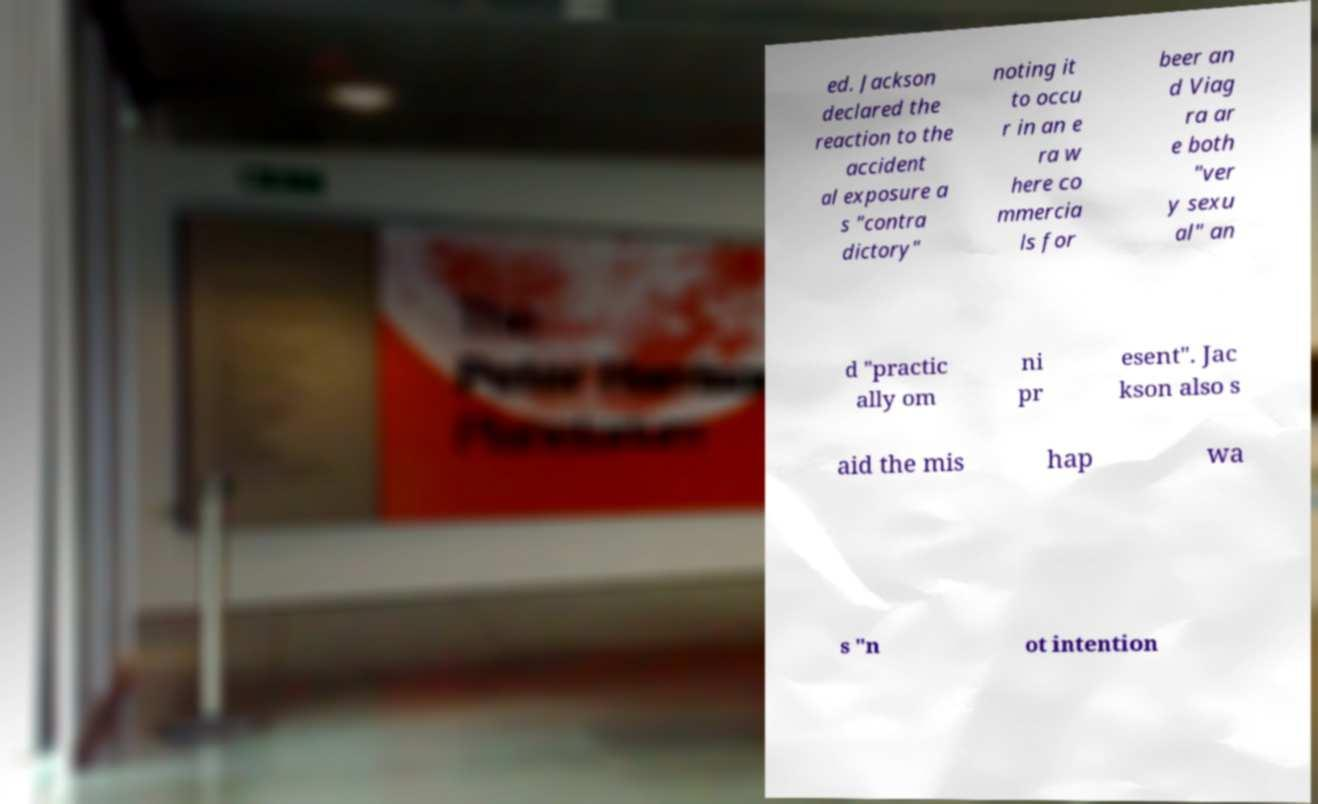Please read and relay the text visible in this image. What does it say? ed. Jackson declared the reaction to the accident al exposure a s "contra dictory" noting it to occu r in an e ra w here co mmercia ls for beer an d Viag ra ar e both "ver y sexu al" an d "practic ally om ni pr esent". Jac kson also s aid the mis hap wa s "n ot intention 